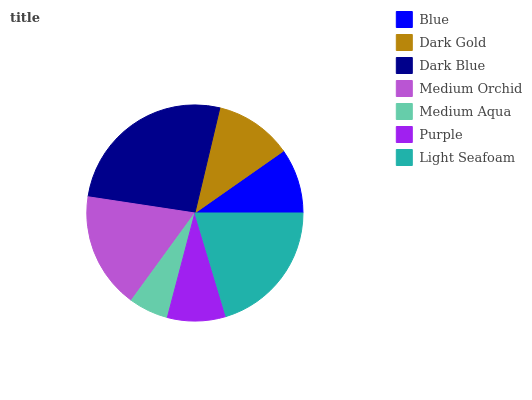Is Medium Aqua the minimum?
Answer yes or no. Yes. Is Dark Blue the maximum?
Answer yes or no. Yes. Is Dark Gold the minimum?
Answer yes or no. No. Is Dark Gold the maximum?
Answer yes or no. No. Is Dark Gold greater than Blue?
Answer yes or no. Yes. Is Blue less than Dark Gold?
Answer yes or no. Yes. Is Blue greater than Dark Gold?
Answer yes or no. No. Is Dark Gold less than Blue?
Answer yes or no. No. Is Dark Gold the high median?
Answer yes or no. Yes. Is Dark Gold the low median?
Answer yes or no. Yes. Is Light Seafoam the high median?
Answer yes or no. No. Is Blue the low median?
Answer yes or no. No. 